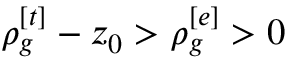Convert formula to latex. <formula><loc_0><loc_0><loc_500><loc_500>\rho _ { g } ^ { [ t ] } - z _ { 0 } > \rho _ { g } ^ { [ e ] } > 0</formula> 